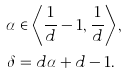Convert formula to latex. <formula><loc_0><loc_0><loc_500><loc_500>\alpha & \in \left \langle { \frac { 1 } { d } - 1 , \frac { 1 } { d } } \right \rangle , \\ \delta & = d \alpha + d - 1 .</formula> 